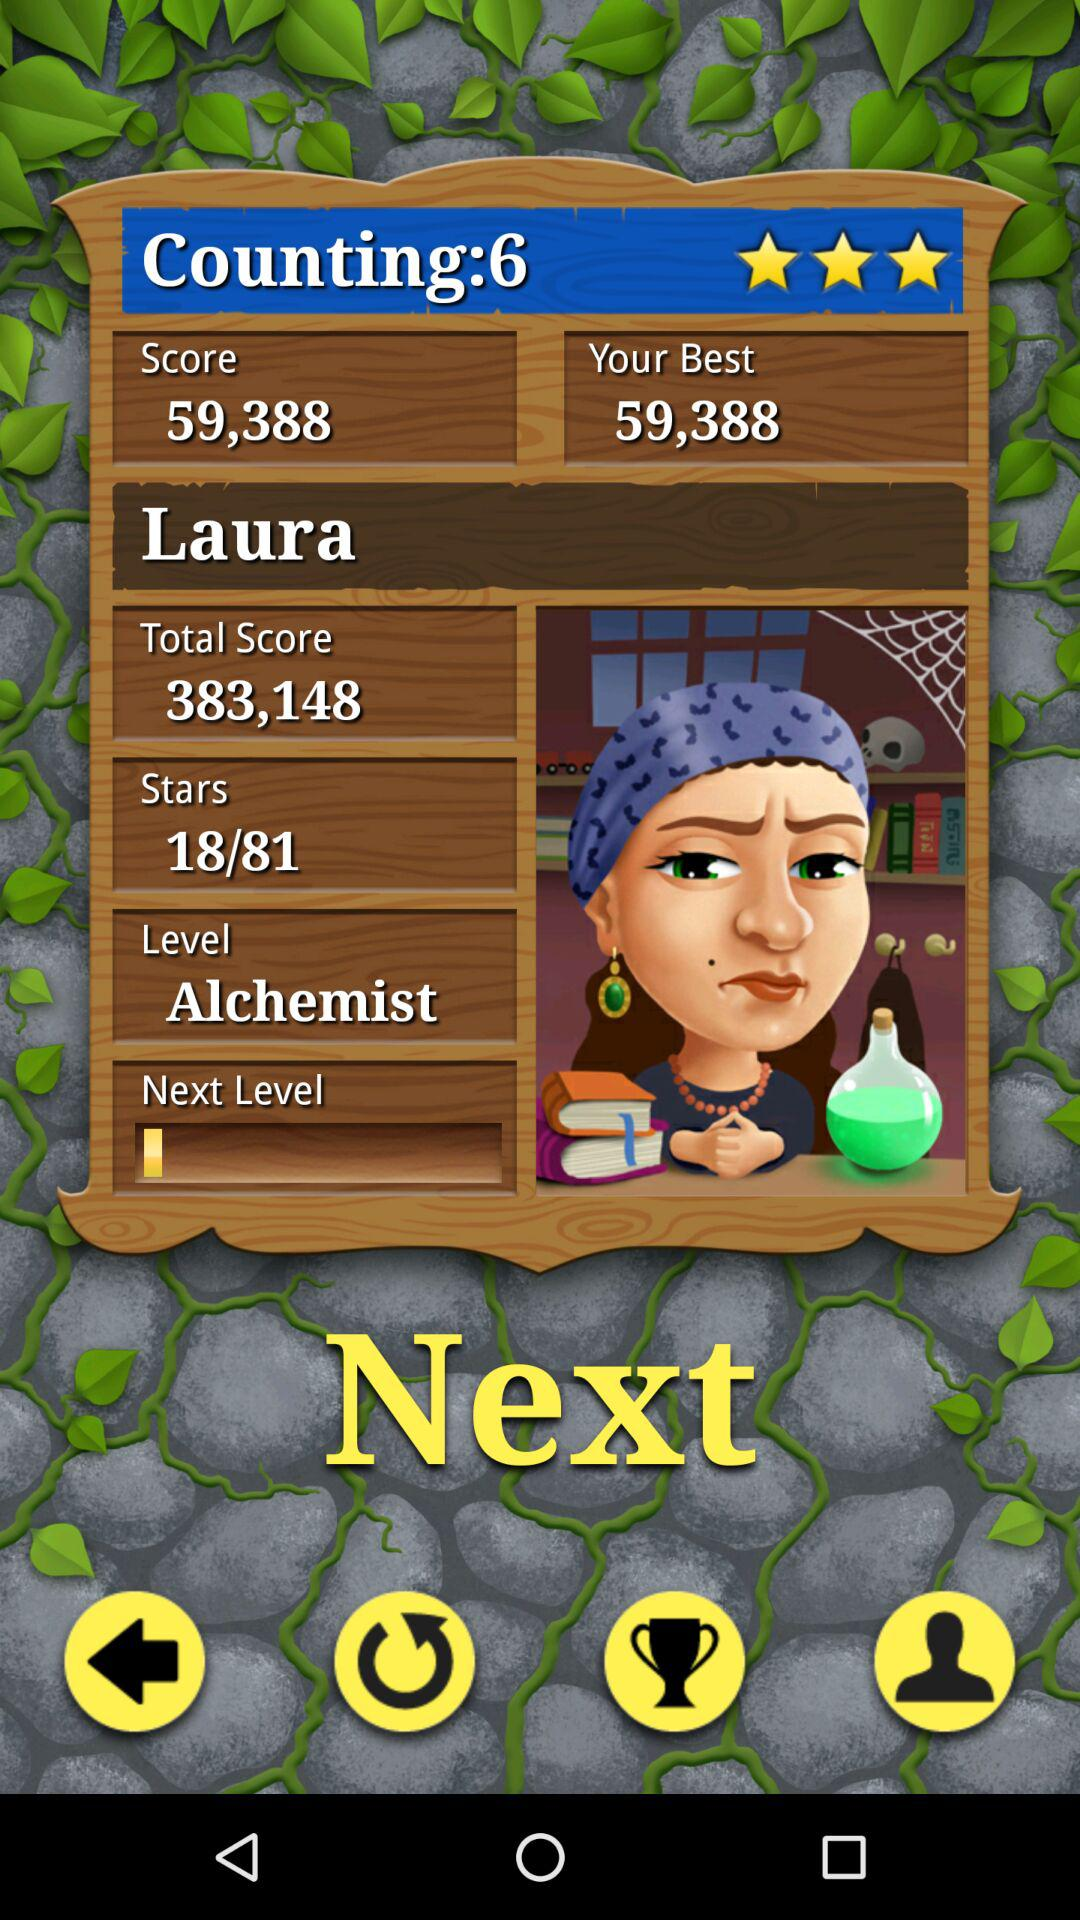What is the name of the character? The name of the character is "Laura". 